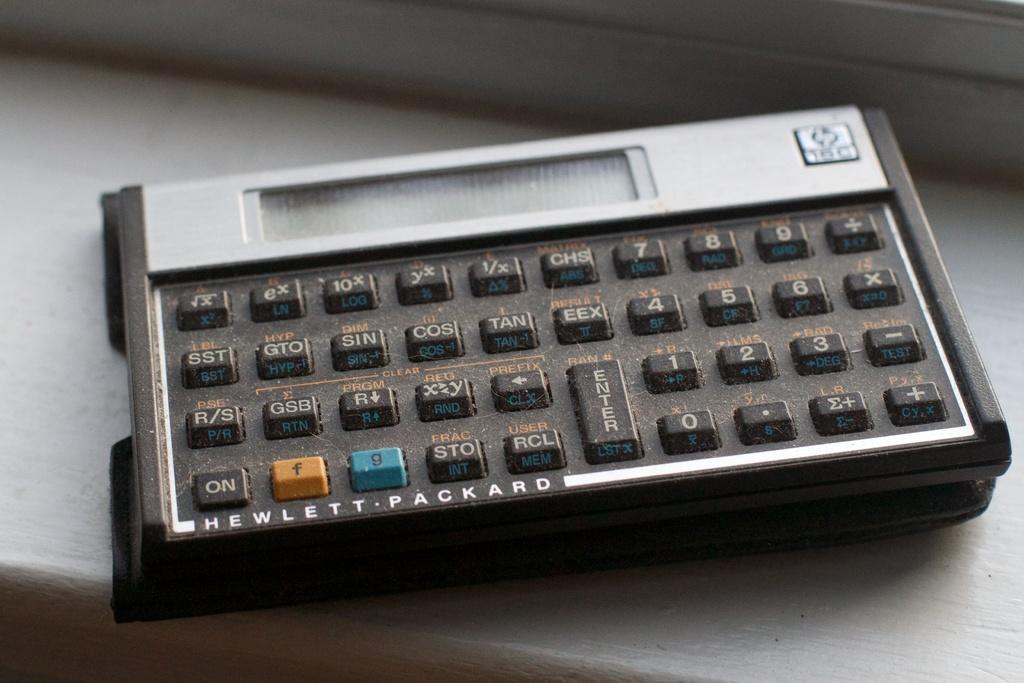Provide a one-sentence caption for the provided image. A Hewlett-Packard calculator is sitting on a ledge. 